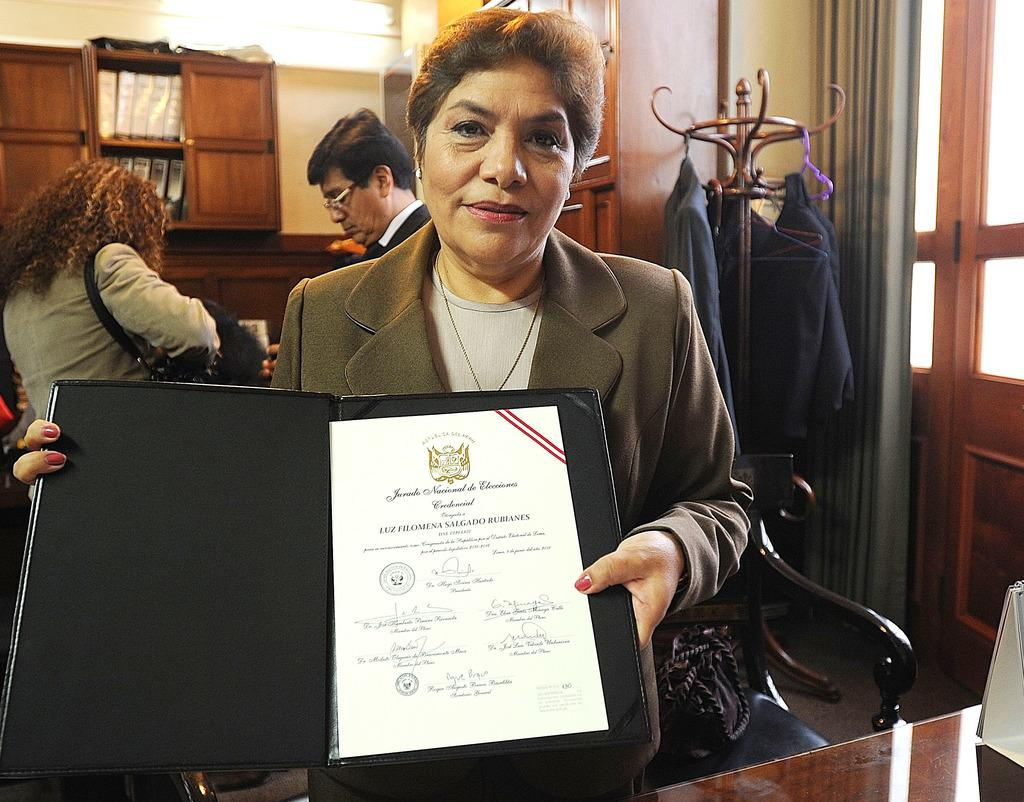How many people are in the image? There are people in the image, but the exact number is not specified. What is the woman holding in her hands? A woman is holding an object in her hands, but the specific object is not described. What can be seen in the background of the image? In the background of the image, there are clothes, cupboards, and curtains, as well as other objects. How does the heat affect the motion of the girl in the image? There is no girl present in the image, and therefore no motion or heat to consider. 